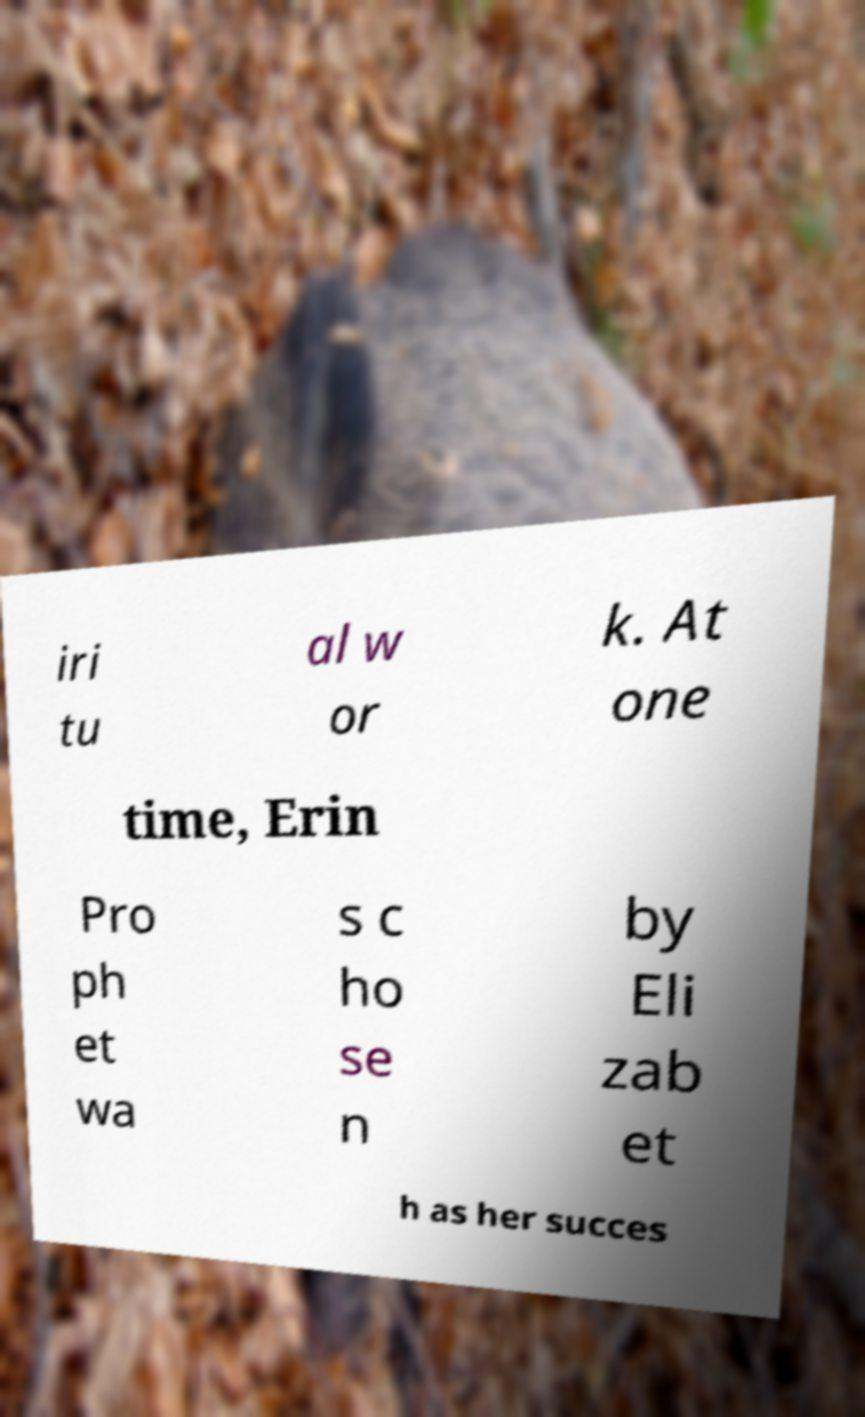I need the written content from this picture converted into text. Can you do that? iri tu al w or k. At one time, Erin Pro ph et wa s c ho se n by Eli zab et h as her succes 